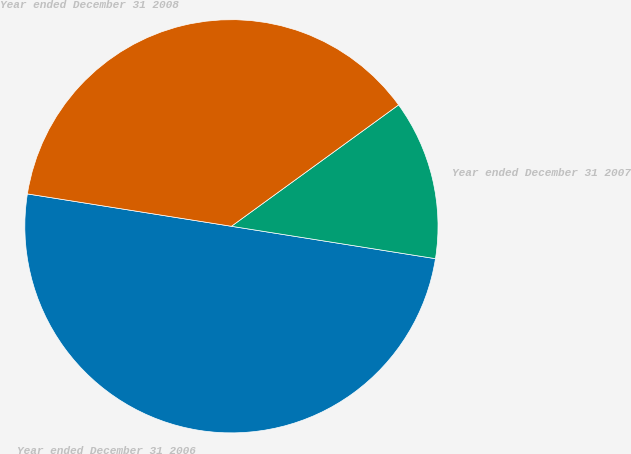Convert chart. <chart><loc_0><loc_0><loc_500><loc_500><pie_chart><fcel>Year ended December 31 2006<fcel>Year ended December 31 2007<fcel>Year ended December 31 2008<nl><fcel>50.0%<fcel>12.5%<fcel>37.5%<nl></chart> 